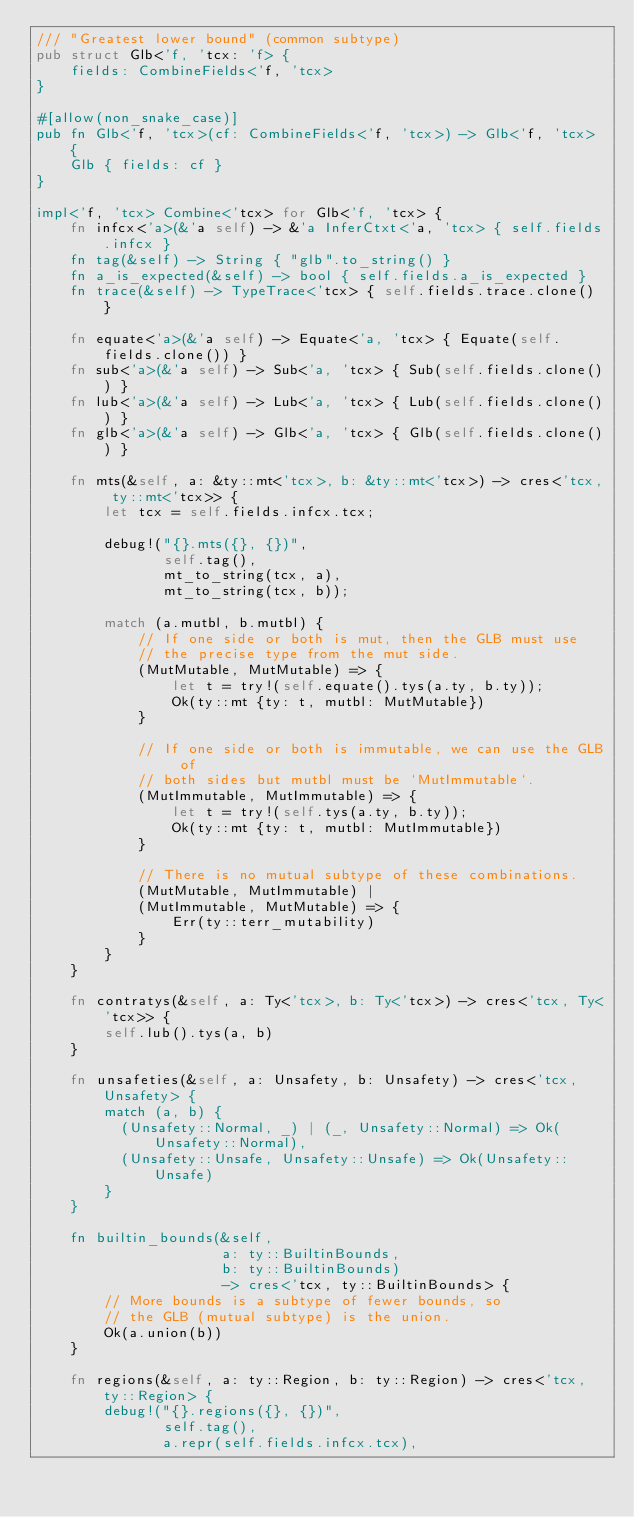<code> <loc_0><loc_0><loc_500><loc_500><_Rust_>/// "Greatest lower bound" (common subtype)
pub struct Glb<'f, 'tcx: 'f> {
    fields: CombineFields<'f, 'tcx>
}

#[allow(non_snake_case)]
pub fn Glb<'f, 'tcx>(cf: CombineFields<'f, 'tcx>) -> Glb<'f, 'tcx> {
    Glb { fields: cf }
}

impl<'f, 'tcx> Combine<'tcx> for Glb<'f, 'tcx> {
    fn infcx<'a>(&'a self) -> &'a InferCtxt<'a, 'tcx> { self.fields.infcx }
    fn tag(&self) -> String { "glb".to_string() }
    fn a_is_expected(&self) -> bool { self.fields.a_is_expected }
    fn trace(&self) -> TypeTrace<'tcx> { self.fields.trace.clone() }

    fn equate<'a>(&'a self) -> Equate<'a, 'tcx> { Equate(self.fields.clone()) }
    fn sub<'a>(&'a self) -> Sub<'a, 'tcx> { Sub(self.fields.clone()) }
    fn lub<'a>(&'a self) -> Lub<'a, 'tcx> { Lub(self.fields.clone()) }
    fn glb<'a>(&'a self) -> Glb<'a, 'tcx> { Glb(self.fields.clone()) }

    fn mts(&self, a: &ty::mt<'tcx>, b: &ty::mt<'tcx>) -> cres<'tcx, ty::mt<'tcx>> {
        let tcx = self.fields.infcx.tcx;

        debug!("{}.mts({}, {})",
               self.tag(),
               mt_to_string(tcx, a),
               mt_to_string(tcx, b));

        match (a.mutbl, b.mutbl) {
            // If one side or both is mut, then the GLB must use
            // the precise type from the mut side.
            (MutMutable, MutMutable) => {
                let t = try!(self.equate().tys(a.ty, b.ty));
                Ok(ty::mt {ty: t, mutbl: MutMutable})
            }

            // If one side or both is immutable, we can use the GLB of
            // both sides but mutbl must be `MutImmutable`.
            (MutImmutable, MutImmutable) => {
                let t = try!(self.tys(a.ty, b.ty));
                Ok(ty::mt {ty: t, mutbl: MutImmutable})
            }

            // There is no mutual subtype of these combinations.
            (MutMutable, MutImmutable) |
            (MutImmutable, MutMutable) => {
                Err(ty::terr_mutability)
            }
        }
    }

    fn contratys(&self, a: Ty<'tcx>, b: Ty<'tcx>) -> cres<'tcx, Ty<'tcx>> {
        self.lub().tys(a, b)
    }

    fn unsafeties(&self, a: Unsafety, b: Unsafety) -> cres<'tcx, Unsafety> {
        match (a, b) {
          (Unsafety::Normal, _) | (_, Unsafety::Normal) => Ok(Unsafety::Normal),
          (Unsafety::Unsafe, Unsafety::Unsafe) => Ok(Unsafety::Unsafe)
        }
    }

    fn builtin_bounds(&self,
                      a: ty::BuiltinBounds,
                      b: ty::BuiltinBounds)
                      -> cres<'tcx, ty::BuiltinBounds> {
        // More bounds is a subtype of fewer bounds, so
        // the GLB (mutual subtype) is the union.
        Ok(a.union(b))
    }

    fn regions(&self, a: ty::Region, b: ty::Region) -> cres<'tcx, ty::Region> {
        debug!("{}.regions({}, {})",
               self.tag(),
               a.repr(self.fields.infcx.tcx),</code> 